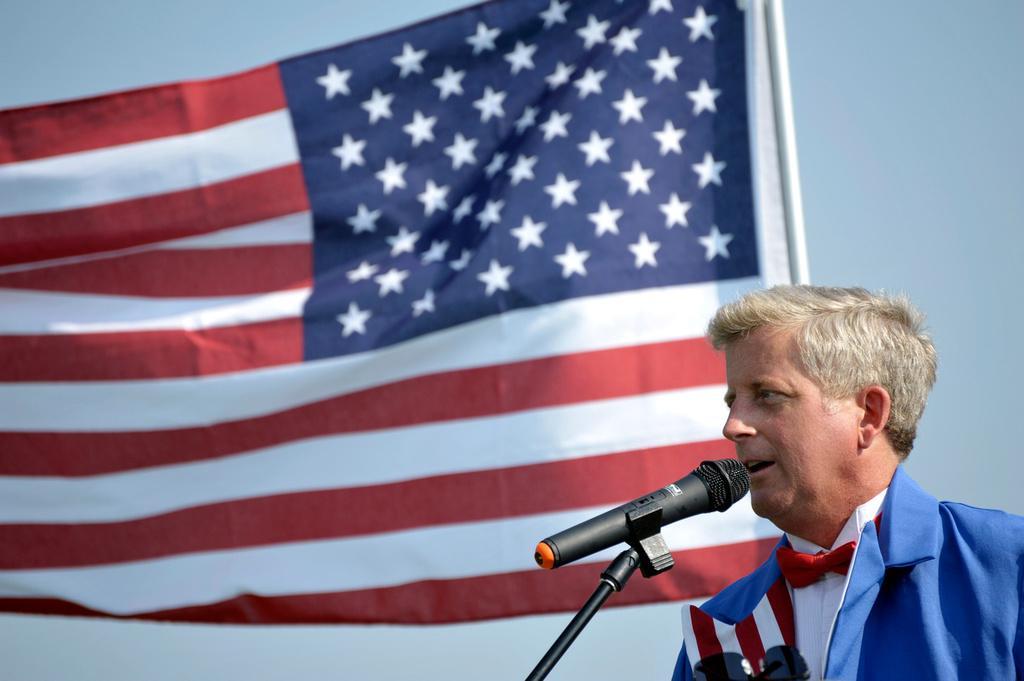In one or two sentences, can you explain what this image depicts? In this image I can see a person wearing white, red and blue colored dress and a black colored microphone in front of him. I can see goggles to his dress. In the background I can see a flag which is red, blue and white in color and the sky. 